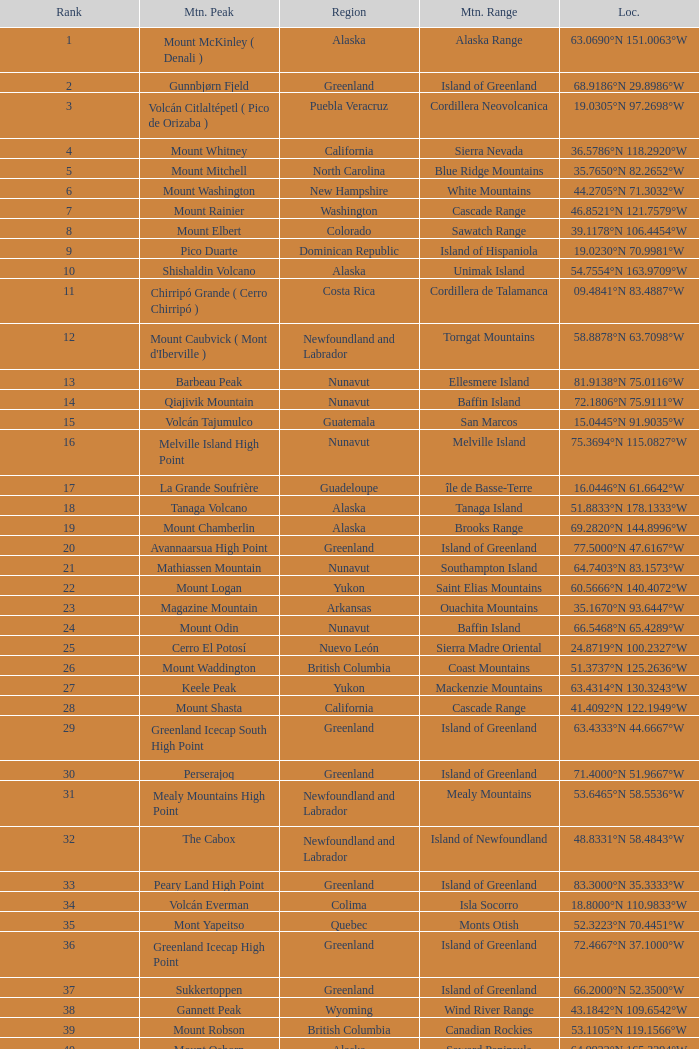Which region has a mountain peak called dillingham high point? Alaska. 